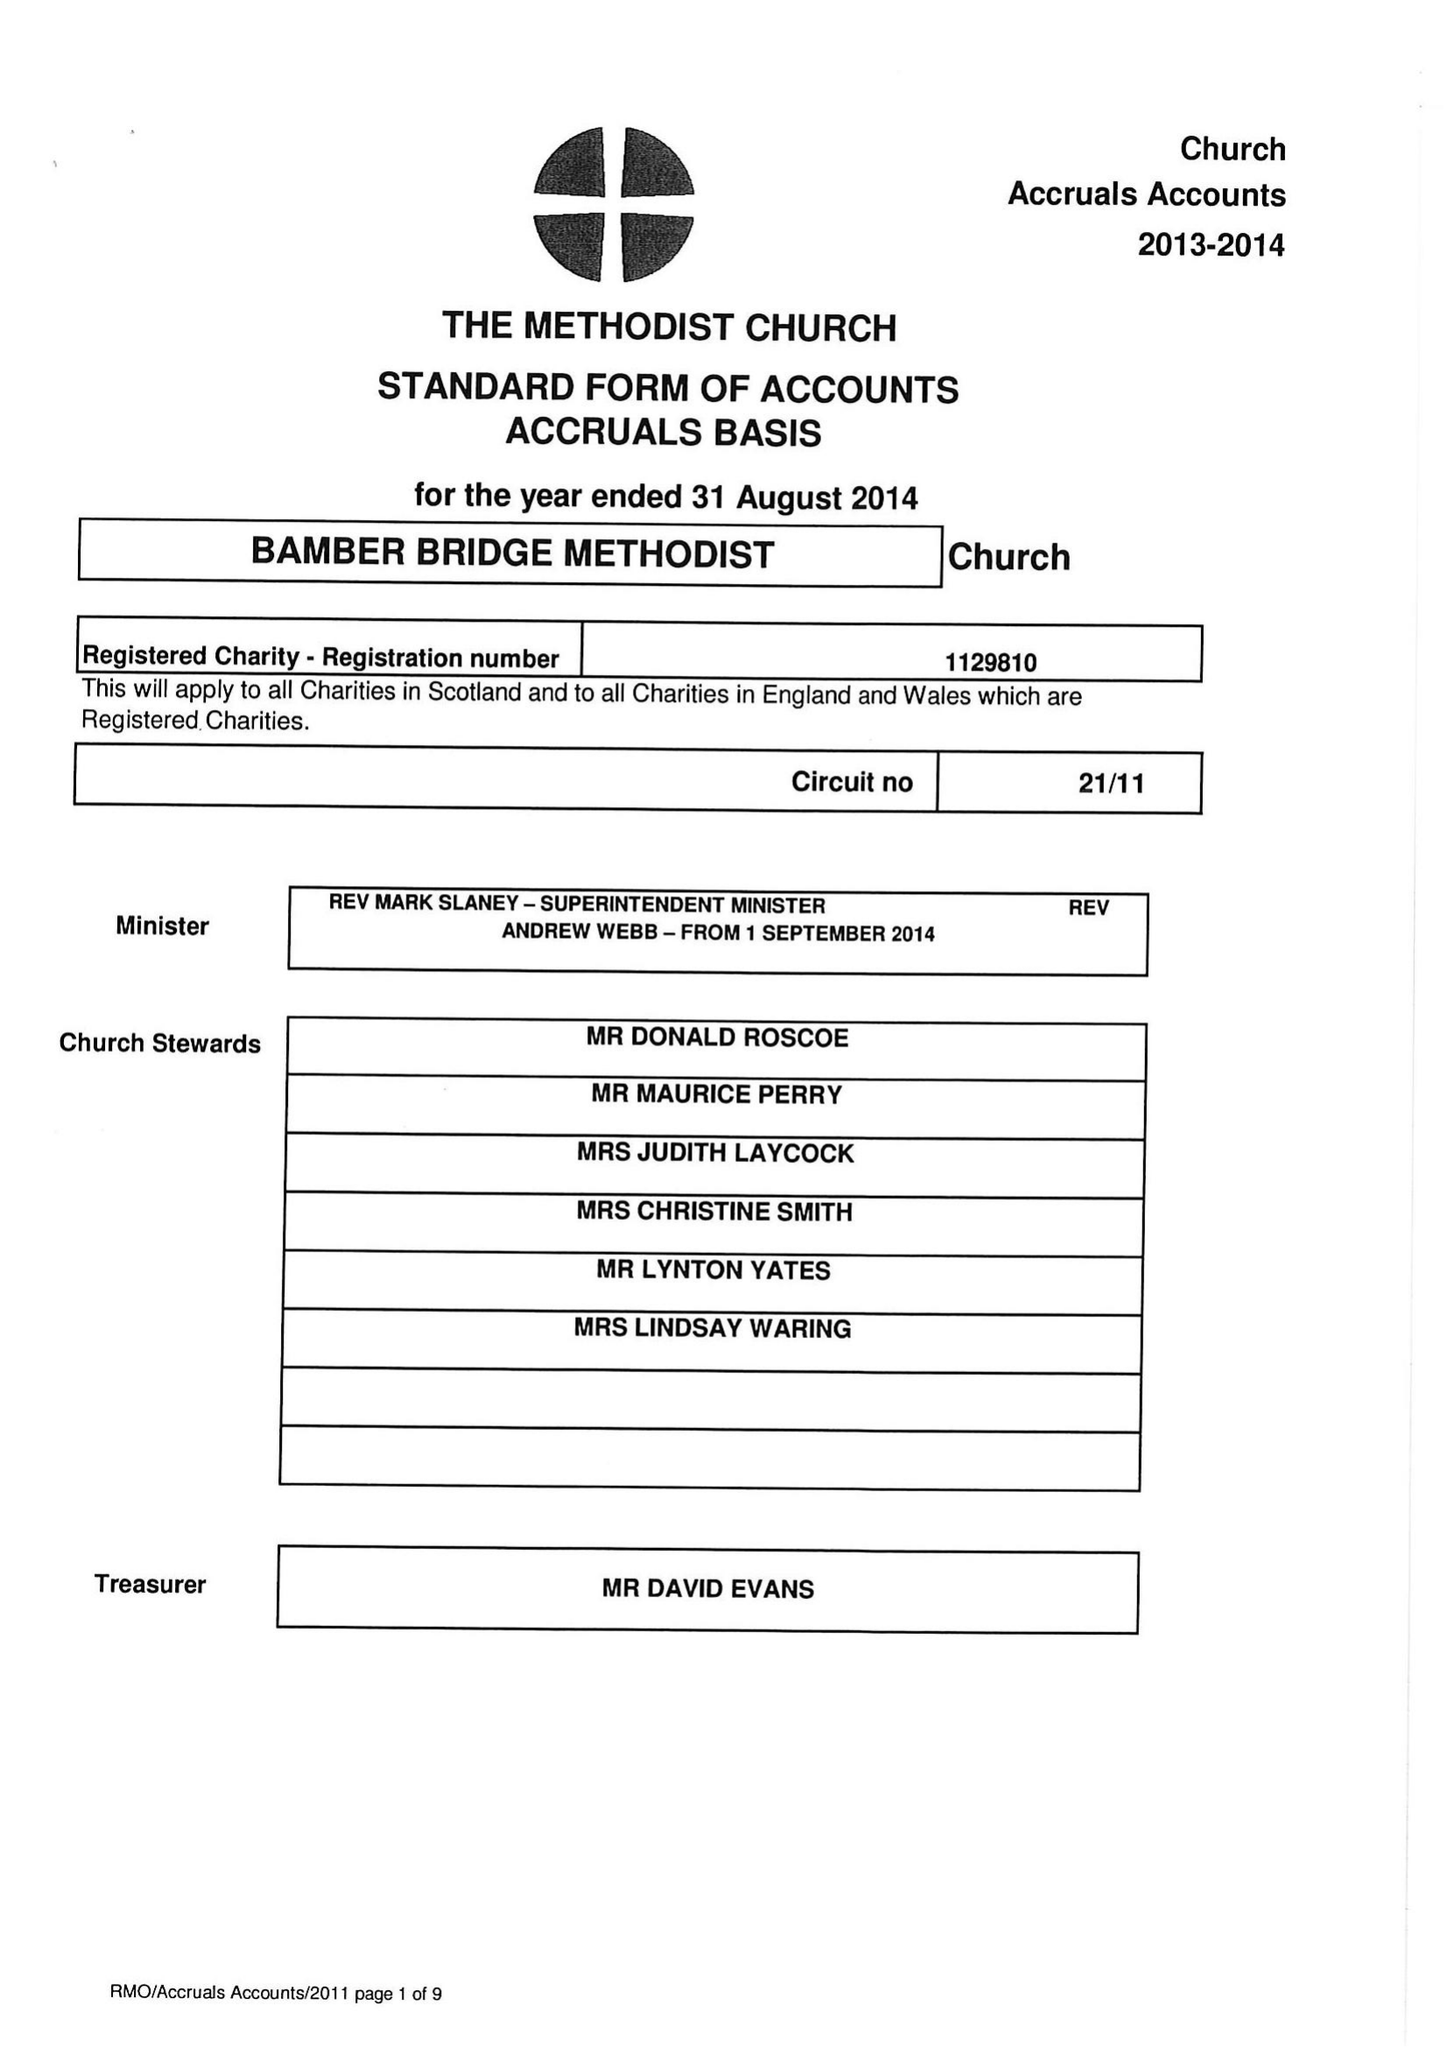What is the value for the spending_annually_in_british_pounds?
Answer the question using a single word or phrase. 115426.00 